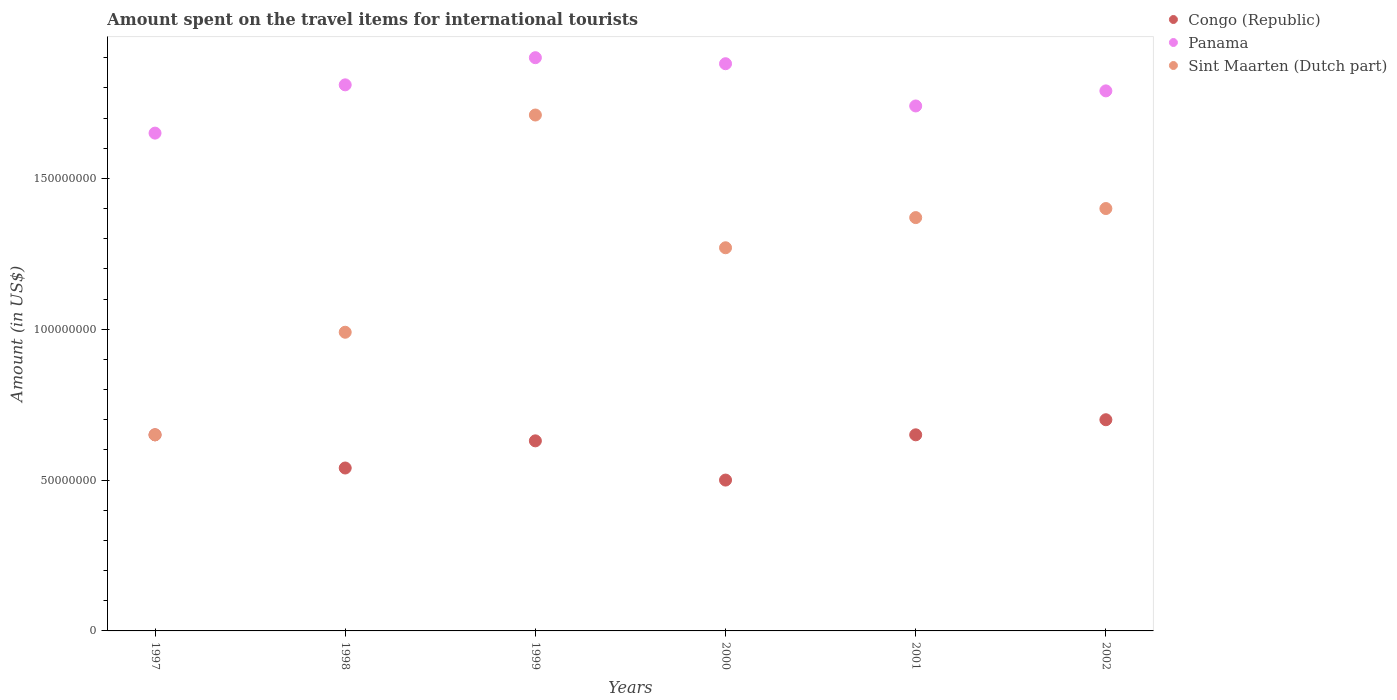What is the amount spent on the travel items for international tourists in Panama in 1998?
Offer a terse response. 1.81e+08. Across all years, what is the maximum amount spent on the travel items for international tourists in Sint Maarten (Dutch part)?
Offer a terse response. 1.71e+08. Across all years, what is the minimum amount spent on the travel items for international tourists in Congo (Republic)?
Offer a very short reply. 5.00e+07. In which year was the amount spent on the travel items for international tourists in Sint Maarten (Dutch part) maximum?
Provide a short and direct response. 1999. In which year was the amount spent on the travel items for international tourists in Sint Maarten (Dutch part) minimum?
Give a very brief answer. 1997. What is the total amount spent on the travel items for international tourists in Congo (Republic) in the graph?
Your answer should be very brief. 3.67e+08. What is the difference between the amount spent on the travel items for international tourists in Panama in 1998 and that in 1999?
Your response must be concise. -9.00e+06. What is the difference between the amount spent on the travel items for international tourists in Sint Maarten (Dutch part) in 2002 and the amount spent on the travel items for international tourists in Congo (Republic) in 1999?
Make the answer very short. 7.70e+07. What is the average amount spent on the travel items for international tourists in Sint Maarten (Dutch part) per year?
Make the answer very short. 1.23e+08. In the year 1999, what is the difference between the amount spent on the travel items for international tourists in Panama and amount spent on the travel items for international tourists in Congo (Republic)?
Your answer should be very brief. 1.27e+08. What is the ratio of the amount spent on the travel items for international tourists in Congo (Republic) in 2000 to that in 2002?
Make the answer very short. 0.71. Is the difference between the amount spent on the travel items for international tourists in Panama in 1997 and 1999 greater than the difference between the amount spent on the travel items for international tourists in Congo (Republic) in 1997 and 1999?
Provide a succinct answer. No. What is the difference between the highest and the second highest amount spent on the travel items for international tourists in Congo (Republic)?
Your answer should be very brief. 5.00e+06. What is the difference between the highest and the lowest amount spent on the travel items for international tourists in Panama?
Your answer should be very brief. 2.50e+07. In how many years, is the amount spent on the travel items for international tourists in Sint Maarten (Dutch part) greater than the average amount spent on the travel items for international tourists in Sint Maarten (Dutch part) taken over all years?
Make the answer very short. 4. Is the sum of the amount spent on the travel items for international tourists in Congo (Republic) in 2001 and 2002 greater than the maximum amount spent on the travel items for international tourists in Sint Maarten (Dutch part) across all years?
Your answer should be very brief. No. Does the amount spent on the travel items for international tourists in Sint Maarten (Dutch part) monotonically increase over the years?
Make the answer very short. No. Is the amount spent on the travel items for international tourists in Sint Maarten (Dutch part) strictly greater than the amount spent on the travel items for international tourists in Panama over the years?
Offer a very short reply. No. Is the amount spent on the travel items for international tourists in Congo (Republic) strictly less than the amount spent on the travel items for international tourists in Sint Maarten (Dutch part) over the years?
Offer a very short reply. No. How many years are there in the graph?
Keep it short and to the point. 6. What is the difference between two consecutive major ticks on the Y-axis?
Your answer should be compact. 5.00e+07. Are the values on the major ticks of Y-axis written in scientific E-notation?
Keep it short and to the point. No. Does the graph contain any zero values?
Your response must be concise. No. Does the graph contain grids?
Ensure brevity in your answer.  No. Where does the legend appear in the graph?
Provide a short and direct response. Top right. How many legend labels are there?
Your answer should be very brief. 3. How are the legend labels stacked?
Give a very brief answer. Vertical. What is the title of the graph?
Your answer should be compact. Amount spent on the travel items for international tourists. Does "Austria" appear as one of the legend labels in the graph?
Ensure brevity in your answer.  No. What is the label or title of the Y-axis?
Provide a short and direct response. Amount (in US$). What is the Amount (in US$) in Congo (Republic) in 1997?
Offer a very short reply. 6.50e+07. What is the Amount (in US$) of Panama in 1997?
Your answer should be very brief. 1.65e+08. What is the Amount (in US$) of Sint Maarten (Dutch part) in 1997?
Keep it short and to the point. 6.50e+07. What is the Amount (in US$) of Congo (Republic) in 1998?
Offer a very short reply. 5.40e+07. What is the Amount (in US$) of Panama in 1998?
Make the answer very short. 1.81e+08. What is the Amount (in US$) of Sint Maarten (Dutch part) in 1998?
Provide a short and direct response. 9.90e+07. What is the Amount (in US$) of Congo (Republic) in 1999?
Provide a succinct answer. 6.30e+07. What is the Amount (in US$) in Panama in 1999?
Ensure brevity in your answer.  1.90e+08. What is the Amount (in US$) of Sint Maarten (Dutch part) in 1999?
Make the answer very short. 1.71e+08. What is the Amount (in US$) of Panama in 2000?
Make the answer very short. 1.88e+08. What is the Amount (in US$) of Sint Maarten (Dutch part) in 2000?
Provide a succinct answer. 1.27e+08. What is the Amount (in US$) of Congo (Republic) in 2001?
Your response must be concise. 6.50e+07. What is the Amount (in US$) of Panama in 2001?
Make the answer very short. 1.74e+08. What is the Amount (in US$) of Sint Maarten (Dutch part) in 2001?
Your answer should be compact. 1.37e+08. What is the Amount (in US$) of Congo (Republic) in 2002?
Provide a short and direct response. 7.00e+07. What is the Amount (in US$) in Panama in 2002?
Provide a short and direct response. 1.79e+08. What is the Amount (in US$) of Sint Maarten (Dutch part) in 2002?
Your response must be concise. 1.40e+08. Across all years, what is the maximum Amount (in US$) of Congo (Republic)?
Give a very brief answer. 7.00e+07. Across all years, what is the maximum Amount (in US$) of Panama?
Your answer should be compact. 1.90e+08. Across all years, what is the maximum Amount (in US$) of Sint Maarten (Dutch part)?
Provide a succinct answer. 1.71e+08. Across all years, what is the minimum Amount (in US$) of Congo (Republic)?
Keep it short and to the point. 5.00e+07. Across all years, what is the minimum Amount (in US$) in Panama?
Offer a terse response. 1.65e+08. Across all years, what is the minimum Amount (in US$) of Sint Maarten (Dutch part)?
Keep it short and to the point. 6.50e+07. What is the total Amount (in US$) in Congo (Republic) in the graph?
Provide a succinct answer. 3.67e+08. What is the total Amount (in US$) in Panama in the graph?
Provide a succinct answer. 1.08e+09. What is the total Amount (in US$) in Sint Maarten (Dutch part) in the graph?
Make the answer very short. 7.39e+08. What is the difference between the Amount (in US$) in Congo (Republic) in 1997 and that in 1998?
Your answer should be very brief. 1.10e+07. What is the difference between the Amount (in US$) of Panama in 1997 and that in 1998?
Your answer should be compact. -1.60e+07. What is the difference between the Amount (in US$) of Sint Maarten (Dutch part) in 1997 and that in 1998?
Your answer should be compact. -3.40e+07. What is the difference between the Amount (in US$) in Congo (Republic) in 1997 and that in 1999?
Your answer should be compact. 2.00e+06. What is the difference between the Amount (in US$) of Panama in 1997 and that in 1999?
Ensure brevity in your answer.  -2.50e+07. What is the difference between the Amount (in US$) of Sint Maarten (Dutch part) in 1997 and that in 1999?
Provide a short and direct response. -1.06e+08. What is the difference between the Amount (in US$) in Congo (Republic) in 1997 and that in 2000?
Ensure brevity in your answer.  1.50e+07. What is the difference between the Amount (in US$) in Panama in 1997 and that in 2000?
Give a very brief answer. -2.30e+07. What is the difference between the Amount (in US$) of Sint Maarten (Dutch part) in 1997 and that in 2000?
Provide a short and direct response. -6.20e+07. What is the difference between the Amount (in US$) in Panama in 1997 and that in 2001?
Keep it short and to the point. -9.00e+06. What is the difference between the Amount (in US$) in Sint Maarten (Dutch part) in 1997 and that in 2001?
Make the answer very short. -7.20e+07. What is the difference between the Amount (in US$) of Congo (Republic) in 1997 and that in 2002?
Offer a very short reply. -5.00e+06. What is the difference between the Amount (in US$) in Panama in 1997 and that in 2002?
Your answer should be very brief. -1.40e+07. What is the difference between the Amount (in US$) in Sint Maarten (Dutch part) in 1997 and that in 2002?
Offer a very short reply. -7.50e+07. What is the difference between the Amount (in US$) of Congo (Republic) in 1998 and that in 1999?
Make the answer very short. -9.00e+06. What is the difference between the Amount (in US$) in Panama in 1998 and that in 1999?
Your response must be concise. -9.00e+06. What is the difference between the Amount (in US$) of Sint Maarten (Dutch part) in 1998 and that in 1999?
Ensure brevity in your answer.  -7.20e+07. What is the difference between the Amount (in US$) of Congo (Republic) in 1998 and that in 2000?
Make the answer very short. 4.00e+06. What is the difference between the Amount (in US$) of Panama in 1998 and that in 2000?
Provide a short and direct response. -7.00e+06. What is the difference between the Amount (in US$) of Sint Maarten (Dutch part) in 1998 and that in 2000?
Your answer should be very brief. -2.80e+07. What is the difference between the Amount (in US$) in Congo (Republic) in 1998 and that in 2001?
Keep it short and to the point. -1.10e+07. What is the difference between the Amount (in US$) of Sint Maarten (Dutch part) in 1998 and that in 2001?
Offer a very short reply. -3.80e+07. What is the difference between the Amount (in US$) of Congo (Republic) in 1998 and that in 2002?
Your response must be concise. -1.60e+07. What is the difference between the Amount (in US$) of Panama in 1998 and that in 2002?
Your response must be concise. 2.00e+06. What is the difference between the Amount (in US$) of Sint Maarten (Dutch part) in 1998 and that in 2002?
Provide a short and direct response. -4.10e+07. What is the difference between the Amount (in US$) of Congo (Republic) in 1999 and that in 2000?
Give a very brief answer. 1.30e+07. What is the difference between the Amount (in US$) of Sint Maarten (Dutch part) in 1999 and that in 2000?
Your answer should be compact. 4.40e+07. What is the difference between the Amount (in US$) of Panama in 1999 and that in 2001?
Your answer should be compact. 1.60e+07. What is the difference between the Amount (in US$) of Sint Maarten (Dutch part) in 1999 and that in 2001?
Give a very brief answer. 3.40e+07. What is the difference between the Amount (in US$) of Congo (Republic) in 1999 and that in 2002?
Your answer should be compact. -7.00e+06. What is the difference between the Amount (in US$) of Panama in 1999 and that in 2002?
Offer a terse response. 1.10e+07. What is the difference between the Amount (in US$) of Sint Maarten (Dutch part) in 1999 and that in 2002?
Give a very brief answer. 3.10e+07. What is the difference between the Amount (in US$) of Congo (Republic) in 2000 and that in 2001?
Provide a short and direct response. -1.50e+07. What is the difference between the Amount (in US$) in Panama in 2000 and that in 2001?
Offer a very short reply. 1.40e+07. What is the difference between the Amount (in US$) of Sint Maarten (Dutch part) in 2000 and that in 2001?
Give a very brief answer. -1.00e+07. What is the difference between the Amount (in US$) of Congo (Republic) in 2000 and that in 2002?
Ensure brevity in your answer.  -2.00e+07. What is the difference between the Amount (in US$) of Panama in 2000 and that in 2002?
Provide a succinct answer. 9.00e+06. What is the difference between the Amount (in US$) of Sint Maarten (Dutch part) in 2000 and that in 2002?
Your answer should be very brief. -1.30e+07. What is the difference between the Amount (in US$) in Congo (Republic) in 2001 and that in 2002?
Your answer should be very brief. -5.00e+06. What is the difference between the Amount (in US$) in Panama in 2001 and that in 2002?
Your answer should be very brief. -5.00e+06. What is the difference between the Amount (in US$) in Sint Maarten (Dutch part) in 2001 and that in 2002?
Provide a short and direct response. -3.00e+06. What is the difference between the Amount (in US$) in Congo (Republic) in 1997 and the Amount (in US$) in Panama in 1998?
Give a very brief answer. -1.16e+08. What is the difference between the Amount (in US$) in Congo (Republic) in 1997 and the Amount (in US$) in Sint Maarten (Dutch part) in 1998?
Your answer should be compact. -3.40e+07. What is the difference between the Amount (in US$) of Panama in 1997 and the Amount (in US$) of Sint Maarten (Dutch part) in 1998?
Make the answer very short. 6.60e+07. What is the difference between the Amount (in US$) of Congo (Republic) in 1997 and the Amount (in US$) of Panama in 1999?
Provide a succinct answer. -1.25e+08. What is the difference between the Amount (in US$) in Congo (Republic) in 1997 and the Amount (in US$) in Sint Maarten (Dutch part) in 1999?
Your response must be concise. -1.06e+08. What is the difference between the Amount (in US$) in Panama in 1997 and the Amount (in US$) in Sint Maarten (Dutch part) in 1999?
Your response must be concise. -6.00e+06. What is the difference between the Amount (in US$) in Congo (Republic) in 1997 and the Amount (in US$) in Panama in 2000?
Keep it short and to the point. -1.23e+08. What is the difference between the Amount (in US$) in Congo (Republic) in 1997 and the Amount (in US$) in Sint Maarten (Dutch part) in 2000?
Provide a short and direct response. -6.20e+07. What is the difference between the Amount (in US$) in Panama in 1997 and the Amount (in US$) in Sint Maarten (Dutch part) in 2000?
Provide a succinct answer. 3.80e+07. What is the difference between the Amount (in US$) of Congo (Republic) in 1997 and the Amount (in US$) of Panama in 2001?
Make the answer very short. -1.09e+08. What is the difference between the Amount (in US$) in Congo (Republic) in 1997 and the Amount (in US$) in Sint Maarten (Dutch part) in 2001?
Provide a short and direct response. -7.20e+07. What is the difference between the Amount (in US$) of Panama in 1997 and the Amount (in US$) of Sint Maarten (Dutch part) in 2001?
Ensure brevity in your answer.  2.80e+07. What is the difference between the Amount (in US$) in Congo (Republic) in 1997 and the Amount (in US$) in Panama in 2002?
Your answer should be very brief. -1.14e+08. What is the difference between the Amount (in US$) in Congo (Republic) in 1997 and the Amount (in US$) in Sint Maarten (Dutch part) in 2002?
Your answer should be compact. -7.50e+07. What is the difference between the Amount (in US$) of Panama in 1997 and the Amount (in US$) of Sint Maarten (Dutch part) in 2002?
Keep it short and to the point. 2.50e+07. What is the difference between the Amount (in US$) in Congo (Republic) in 1998 and the Amount (in US$) in Panama in 1999?
Offer a terse response. -1.36e+08. What is the difference between the Amount (in US$) of Congo (Republic) in 1998 and the Amount (in US$) of Sint Maarten (Dutch part) in 1999?
Provide a succinct answer. -1.17e+08. What is the difference between the Amount (in US$) of Panama in 1998 and the Amount (in US$) of Sint Maarten (Dutch part) in 1999?
Your answer should be compact. 1.00e+07. What is the difference between the Amount (in US$) of Congo (Republic) in 1998 and the Amount (in US$) of Panama in 2000?
Keep it short and to the point. -1.34e+08. What is the difference between the Amount (in US$) in Congo (Republic) in 1998 and the Amount (in US$) in Sint Maarten (Dutch part) in 2000?
Your answer should be compact. -7.30e+07. What is the difference between the Amount (in US$) in Panama in 1998 and the Amount (in US$) in Sint Maarten (Dutch part) in 2000?
Your response must be concise. 5.40e+07. What is the difference between the Amount (in US$) in Congo (Republic) in 1998 and the Amount (in US$) in Panama in 2001?
Your answer should be very brief. -1.20e+08. What is the difference between the Amount (in US$) in Congo (Republic) in 1998 and the Amount (in US$) in Sint Maarten (Dutch part) in 2001?
Offer a terse response. -8.30e+07. What is the difference between the Amount (in US$) of Panama in 1998 and the Amount (in US$) of Sint Maarten (Dutch part) in 2001?
Provide a short and direct response. 4.40e+07. What is the difference between the Amount (in US$) of Congo (Republic) in 1998 and the Amount (in US$) of Panama in 2002?
Your answer should be compact. -1.25e+08. What is the difference between the Amount (in US$) of Congo (Republic) in 1998 and the Amount (in US$) of Sint Maarten (Dutch part) in 2002?
Your response must be concise. -8.60e+07. What is the difference between the Amount (in US$) of Panama in 1998 and the Amount (in US$) of Sint Maarten (Dutch part) in 2002?
Give a very brief answer. 4.10e+07. What is the difference between the Amount (in US$) of Congo (Republic) in 1999 and the Amount (in US$) of Panama in 2000?
Ensure brevity in your answer.  -1.25e+08. What is the difference between the Amount (in US$) of Congo (Republic) in 1999 and the Amount (in US$) of Sint Maarten (Dutch part) in 2000?
Your answer should be very brief. -6.40e+07. What is the difference between the Amount (in US$) of Panama in 1999 and the Amount (in US$) of Sint Maarten (Dutch part) in 2000?
Make the answer very short. 6.30e+07. What is the difference between the Amount (in US$) of Congo (Republic) in 1999 and the Amount (in US$) of Panama in 2001?
Make the answer very short. -1.11e+08. What is the difference between the Amount (in US$) in Congo (Republic) in 1999 and the Amount (in US$) in Sint Maarten (Dutch part) in 2001?
Offer a terse response. -7.40e+07. What is the difference between the Amount (in US$) of Panama in 1999 and the Amount (in US$) of Sint Maarten (Dutch part) in 2001?
Give a very brief answer. 5.30e+07. What is the difference between the Amount (in US$) in Congo (Republic) in 1999 and the Amount (in US$) in Panama in 2002?
Offer a terse response. -1.16e+08. What is the difference between the Amount (in US$) in Congo (Republic) in 1999 and the Amount (in US$) in Sint Maarten (Dutch part) in 2002?
Make the answer very short. -7.70e+07. What is the difference between the Amount (in US$) in Panama in 1999 and the Amount (in US$) in Sint Maarten (Dutch part) in 2002?
Your response must be concise. 5.00e+07. What is the difference between the Amount (in US$) in Congo (Republic) in 2000 and the Amount (in US$) in Panama in 2001?
Make the answer very short. -1.24e+08. What is the difference between the Amount (in US$) in Congo (Republic) in 2000 and the Amount (in US$) in Sint Maarten (Dutch part) in 2001?
Ensure brevity in your answer.  -8.70e+07. What is the difference between the Amount (in US$) in Panama in 2000 and the Amount (in US$) in Sint Maarten (Dutch part) in 2001?
Ensure brevity in your answer.  5.10e+07. What is the difference between the Amount (in US$) in Congo (Republic) in 2000 and the Amount (in US$) in Panama in 2002?
Provide a succinct answer. -1.29e+08. What is the difference between the Amount (in US$) in Congo (Republic) in 2000 and the Amount (in US$) in Sint Maarten (Dutch part) in 2002?
Make the answer very short. -9.00e+07. What is the difference between the Amount (in US$) in Panama in 2000 and the Amount (in US$) in Sint Maarten (Dutch part) in 2002?
Give a very brief answer. 4.80e+07. What is the difference between the Amount (in US$) of Congo (Republic) in 2001 and the Amount (in US$) of Panama in 2002?
Make the answer very short. -1.14e+08. What is the difference between the Amount (in US$) in Congo (Republic) in 2001 and the Amount (in US$) in Sint Maarten (Dutch part) in 2002?
Your answer should be very brief. -7.50e+07. What is the difference between the Amount (in US$) of Panama in 2001 and the Amount (in US$) of Sint Maarten (Dutch part) in 2002?
Ensure brevity in your answer.  3.40e+07. What is the average Amount (in US$) of Congo (Republic) per year?
Your response must be concise. 6.12e+07. What is the average Amount (in US$) of Panama per year?
Your response must be concise. 1.80e+08. What is the average Amount (in US$) of Sint Maarten (Dutch part) per year?
Keep it short and to the point. 1.23e+08. In the year 1997, what is the difference between the Amount (in US$) in Congo (Republic) and Amount (in US$) in Panama?
Your answer should be very brief. -1.00e+08. In the year 1997, what is the difference between the Amount (in US$) of Congo (Republic) and Amount (in US$) of Sint Maarten (Dutch part)?
Offer a very short reply. 0. In the year 1997, what is the difference between the Amount (in US$) in Panama and Amount (in US$) in Sint Maarten (Dutch part)?
Offer a very short reply. 1.00e+08. In the year 1998, what is the difference between the Amount (in US$) in Congo (Republic) and Amount (in US$) in Panama?
Keep it short and to the point. -1.27e+08. In the year 1998, what is the difference between the Amount (in US$) of Congo (Republic) and Amount (in US$) of Sint Maarten (Dutch part)?
Give a very brief answer. -4.50e+07. In the year 1998, what is the difference between the Amount (in US$) in Panama and Amount (in US$) in Sint Maarten (Dutch part)?
Your answer should be compact. 8.20e+07. In the year 1999, what is the difference between the Amount (in US$) in Congo (Republic) and Amount (in US$) in Panama?
Ensure brevity in your answer.  -1.27e+08. In the year 1999, what is the difference between the Amount (in US$) in Congo (Republic) and Amount (in US$) in Sint Maarten (Dutch part)?
Your answer should be very brief. -1.08e+08. In the year 1999, what is the difference between the Amount (in US$) in Panama and Amount (in US$) in Sint Maarten (Dutch part)?
Provide a succinct answer. 1.90e+07. In the year 2000, what is the difference between the Amount (in US$) of Congo (Republic) and Amount (in US$) of Panama?
Provide a short and direct response. -1.38e+08. In the year 2000, what is the difference between the Amount (in US$) in Congo (Republic) and Amount (in US$) in Sint Maarten (Dutch part)?
Ensure brevity in your answer.  -7.70e+07. In the year 2000, what is the difference between the Amount (in US$) in Panama and Amount (in US$) in Sint Maarten (Dutch part)?
Your answer should be compact. 6.10e+07. In the year 2001, what is the difference between the Amount (in US$) of Congo (Republic) and Amount (in US$) of Panama?
Offer a terse response. -1.09e+08. In the year 2001, what is the difference between the Amount (in US$) of Congo (Republic) and Amount (in US$) of Sint Maarten (Dutch part)?
Offer a terse response. -7.20e+07. In the year 2001, what is the difference between the Amount (in US$) in Panama and Amount (in US$) in Sint Maarten (Dutch part)?
Your answer should be compact. 3.70e+07. In the year 2002, what is the difference between the Amount (in US$) of Congo (Republic) and Amount (in US$) of Panama?
Offer a very short reply. -1.09e+08. In the year 2002, what is the difference between the Amount (in US$) in Congo (Republic) and Amount (in US$) in Sint Maarten (Dutch part)?
Ensure brevity in your answer.  -7.00e+07. In the year 2002, what is the difference between the Amount (in US$) in Panama and Amount (in US$) in Sint Maarten (Dutch part)?
Make the answer very short. 3.90e+07. What is the ratio of the Amount (in US$) in Congo (Republic) in 1997 to that in 1998?
Provide a succinct answer. 1.2. What is the ratio of the Amount (in US$) in Panama in 1997 to that in 1998?
Provide a short and direct response. 0.91. What is the ratio of the Amount (in US$) of Sint Maarten (Dutch part) in 1997 to that in 1998?
Your answer should be very brief. 0.66. What is the ratio of the Amount (in US$) of Congo (Republic) in 1997 to that in 1999?
Provide a short and direct response. 1.03. What is the ratio of the Amount (in US$) of Panama in 1997 to that in 1999?
Make the answer very short. 0.87. What is the ratio of the Amount (in US$) of Sint Maarten (Dutch part) in 1997 to that in 1999?
Your answer should be compact. 0.38. What is the ratio of the Amount (in US$) in Congo (Republic) in 1997 to that in 2000?
Your answer should be very brief. 1.3. What is the ratio of the Amount (in US$) in Panama in 1997 to that in 2000?
Offer a terse response. 0.88. What is the ratio of the Amount (in US$) in Sint Maarten (Dutch part) in 1997 to that in 2000?
Ensure brevity in your answer.  0.51. What is the ratio of the Amount (in US$) of Congo (Republic) in 1997 to that in 2001?
Offer a very short reply. 1. What is the ratio of the Amount (in US$) of Panama in 1997 to that in 2001?
Your answer should be compact. 0.95. What is the ratio of the Amount (in US$) of Sint Maarten (Dutch part) in 1997 to that in 2001?
Your response must be concise. 0.47. What is the ratio of the Amount (in US$) of Congo (Republic) in 1997 to that in 2002?
Ensure brevity in your answer.  0.93. What is the ratio of the Amount (in US$) in Panama in 1997 to that in 2002?
Your response must be concise. 0.92. What is the ratio of the Amount (in US$) of Sint Maarten (Dutch part) in 1997 to that in 2002?
Give a very brief answer. 0.46. What is the ratio of the Amount (in US$) of Panama in 1998 to that in 1999?
Make the answer very short. 0.95. What is the ratio of the Amount (in US$) of Sint Maarten (Dutch part) in 1998 to that in 1999?
Offer a very short reply. 0.58. What is the ratio of the Amount (in US$) in Congo (Republic) in 1998 to that in 2000?
Your answer should be very brief. 1.08. What is the ratio of the Amount (in US$) of Panama in 1998 to that in 2000?
Give a very brief answer. 0.96. What is the ratio of the Amount (in US$) of Sint Maarten (Dutch part) in 1998 to that in 2000?
Make the answer very short. 0.78. What is the ratio of the Amount (in US$) of Congo (Republic) in 1998 to that in 2001?
Ensure brevity in your answer.  0.83. What is the ratio of the Amount (in US$) in Panama in 1998 to that in 2001?
Your answer should be compact. 1.04. What is the ratio of the Amount (in US$) of Sint Maarten (Dutch part) in 1998 to that in 2001?
Give a very brief answer. 0.72. What is the ratio of the Amount (in US$) of Congo (Republic) in 1998 to that in 2002?
Provide a short and direct response. 0.77. What is the ratio of the Amount (in US$) in Panama in 1998 to that in 2002?
Your answer should be compact. 1.01. What is the ratio of the Amount (in US$) of Sint Maarten (Dutch part) in 1998 to that in 2002?
Provide a short and direct response. 0.71. What is the ratio of the Amount (in US$) of Congo (Republic) in 1999 to that in 2000?
Give a very brief answer. 1.26. What is the ratio of the Amount (in US$) of Panama in 1999 to that in 2000?
Keep it short and to the point. 1.01. What is the ratio of the Amount (in US$) of Sint Maarten (Dutch part) in 1999 to that in 2000?
Your answer should be compact. 1.35. What is the ratio of the Amount (in US$) in Congo (Republic) in 1999 to that in 2001?
Ensure brevity in your answer.  0.97. What is the ratio of the Amount (in US$) in Panama in 1999 to that in 2001?
Provide a short and direct response. 1.09. What is the ratio of the Amount (in US$) of Sint Maarten (Dutch part) in 1999 to that in 2001?
Give a very brief answer. 1.25. What is the ratio of the Amount (in US$) in Congo (Republic) in 1999 to that in 2002?
Your response must be concise. 0.9. What is the ratio of the Amount (in US$) in Panama in 1999 to that in 2002?
Provide a succinct answer. 1.06. What is the ratio of the Amount (in US$) of Sint Maarten (Dutch part) in 1999 to that in 2002?
Offer a terse response. 1.22. What is the ratio of the Amount (in US$) in Congo (Republic) in 2000 to that in 2001?
Give a very brief answer. 0.77. What is the ratio of the Amount (in US$) in Panama in 2000 to that in 2001?
Make the answer very short. 1.08. What is the ratio of the Amount (in US$) of Sint Maarten (Dutch part) in 2000 to that in 2001?
Your response must be concise. 0.93. What is the ratio of the Amount (in US$) in Congo (Republic) in 2000 to that in 2002?
Offer a very short reply. 0.71. What is the ratio of the Amount (in US$) of Panama in 2000 to that in 2002?
Offer a very short reply. 1.05. What is the ratio of the Amount (in US$) of Sint Maarten (Dutch part) in 2000 to that in 2002?
Provide a succinct answer. 0.91. What is the ratio of the Amount (in US$) in Panama in 2001 to that in 2002?
Your answer should be very brief. 0.97. What is the ratio of the Amount (in US$) in Sint Maarten (Dutch part) in 2001 to that in 2002?
Your answer should be compact. 0.98. What is the difference between the highest and the second highest Amount (in US$) of Congo (Republic)?
Provide a succinct answer. 5.00e+06. What is the difference between the highest and the second highest Amount (in US$) in Sint Maarten (Dutch part)?
Offer a very short reply. 3.10e+07. What is the difference between the highest and the lowest Amount (in US$) in Panama?
Make the answer very short. 2.50e+07. What is the difference between the highest and the lowest Amount (in US$) in Sint Maarten (Dutch part)?
Make the answer very short. 1.06e+08. 